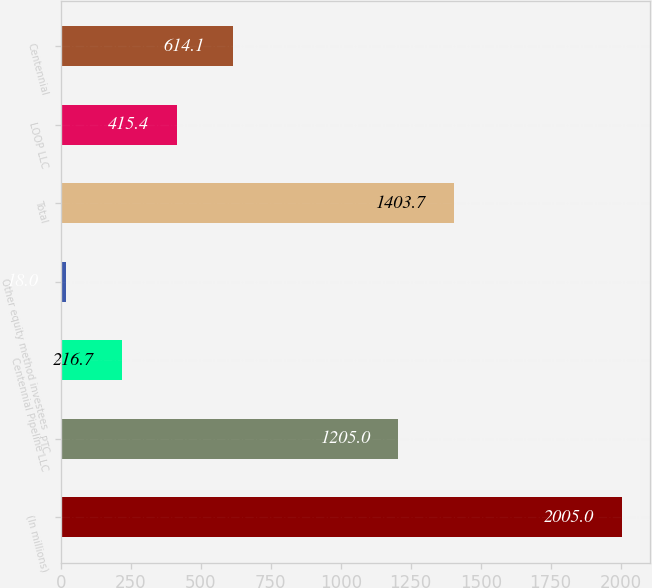Convert chart. <chart><loc_0><loc_0><loc_500><loc_500><bar_chart><fcel>(In millions)<fcel>PTC<fcel>Centennial Pipeline LLC<fcel>Other equity method investees<fcel>Total<fcel>LOOP LLC<fcel>Centennial<nl><fcel>2005<fcel>1205<fcel>216.7<fcel>18<fcel>1403.7<fcel>415.4<fcel>614.1<nl></chart> 